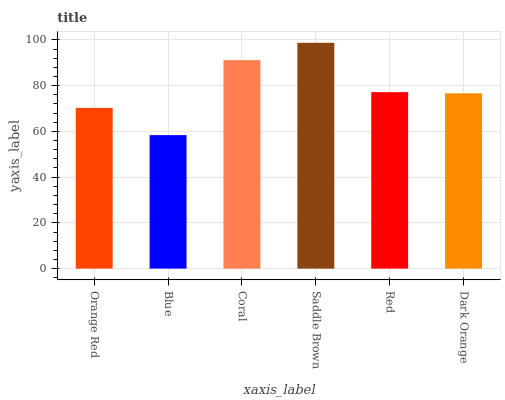Is Blue the minimum?
Answer yes or no. Yes. Is Saddle Brown the maximum?
Answer yes or no. Yes. Is Coral the minimum?
Answer yes or no. No. Is Coral the maximum?
Answer yes or no. No. Is Coral greater than Blue?
Answer yes or no. Yes. Is Blue less than Coral?
Answer yes or no. Yes. Is Blue greater than Coral?
Answer yes or no. No. Is Coral less than Blue?
Answer yes or no. No. Is Red the high median?
Answer yes or no. Yes. Is Dark Orange the low median?
Answer yes or no. Yes. Is Dark Orange the high median?
Answer yes or no. No. Is Blue the low median?
Answer yes or no. No. 